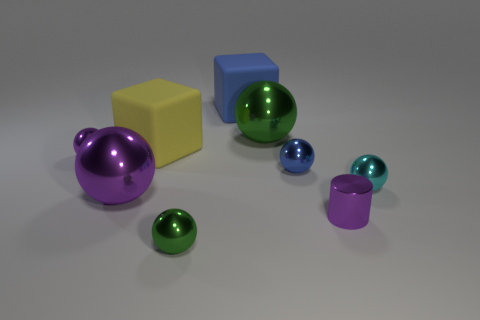Subtract 1 balls. How many balls are left? 5 Subtract all green spheres. How many spheres are left? 4 Subtract all tiny cyan spheres. How many spheres are left? 5 Add 1 small yellow objects. How many objects exist? 10 Subtract all blue spheres. Subtract all brown cylinders. How many spheres are left? 5 Subtract all balls. How many objects are left? 3 Add 9 yellow blocks. How many yellow blocks exist? 10 Subtract 0 gray spheres. How many objects are left? 9 Subtract all large yellow objects. Subtract all purple cylinders. How many objects are left? 7 Add 8 large blue objects. How many large blue objects are left? 9 